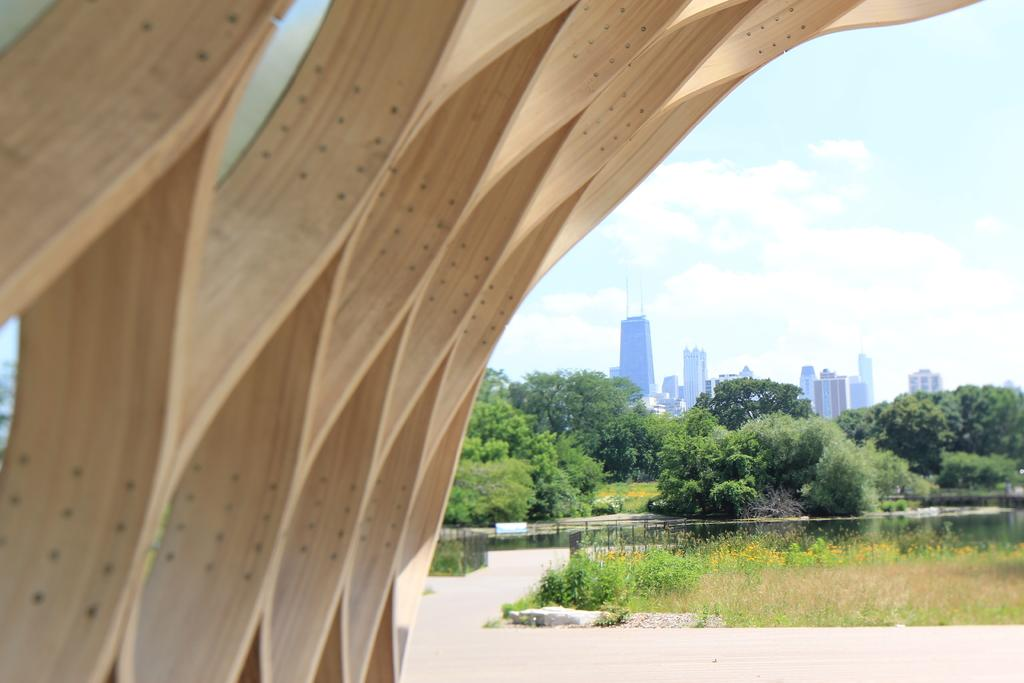What is located on the left side of the image? There is a construction on the left side of the image. What type of vegetation can be seen on the right side of the image? Plants and trees are present on the right side of the image. What can be seen in the background of the image? Buildings are visible in the background of the image. What is visible in the sky in the image? The sky is visible in the image, and clouds are present in it. What type of rhythm can be heard coming from the construction site in the image? There is no sound or rhythm present in the image, as it is a still photograph. Are there any tomatoes growing on the plants and trees in the image? There is no indication of tomatoes or any specific type of plant in the image; only plants and trees are mentioned. 